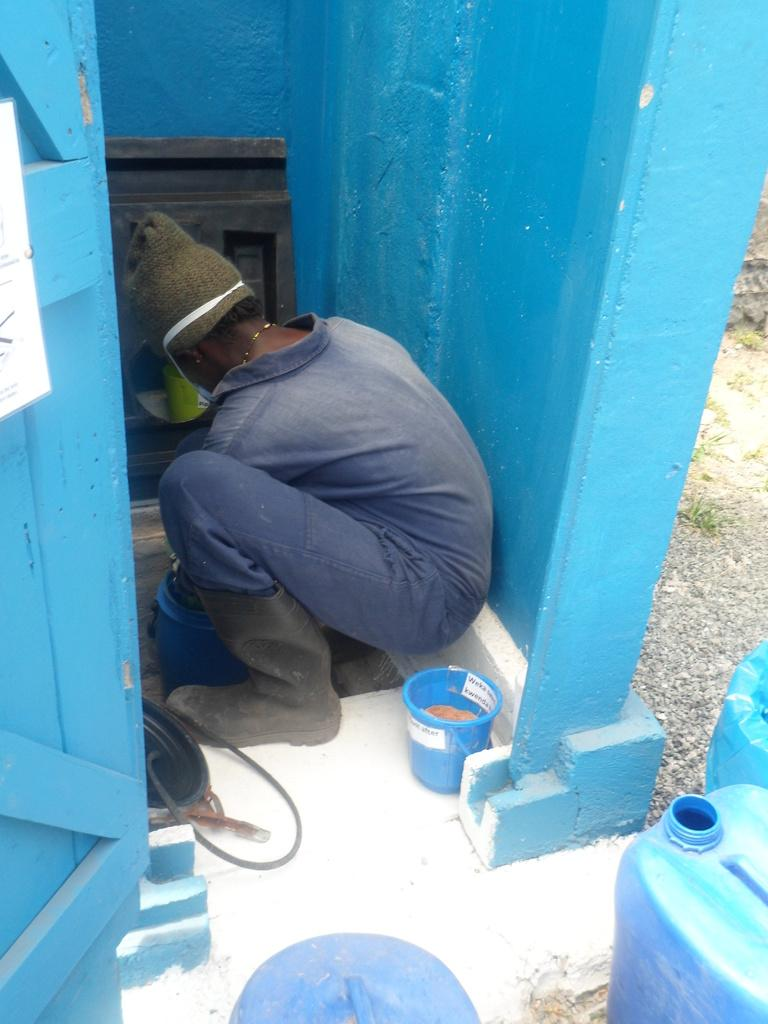Who or what is present in the image? There is a person in the image. What object can be seen near the person? There is a bucket in the image. What type of containers are visible in the image? There are cans in the image. What is the background of the image? There is a wall in the image. Can you describe any other objects in the image? There are unspecified objects in the image. Reasoning: Let' Let's think step by step in order to produce the conversation. We start by identifying the main subject in the image, which is the person. Then, we expand the conversation to include other objects that are also visible, such as the bucket, cans, wall, and unspecified objects. Each question is designed to elicit a specific detail about the image that is known from the provided facts. Absurd Question/Answer: What type of food is the beetle eating in the image? There is no beetle present in the image, so it is not possible to determine what type of food it might be eating. What type of pipe is visible in the image? There is no pipe present in the image. 